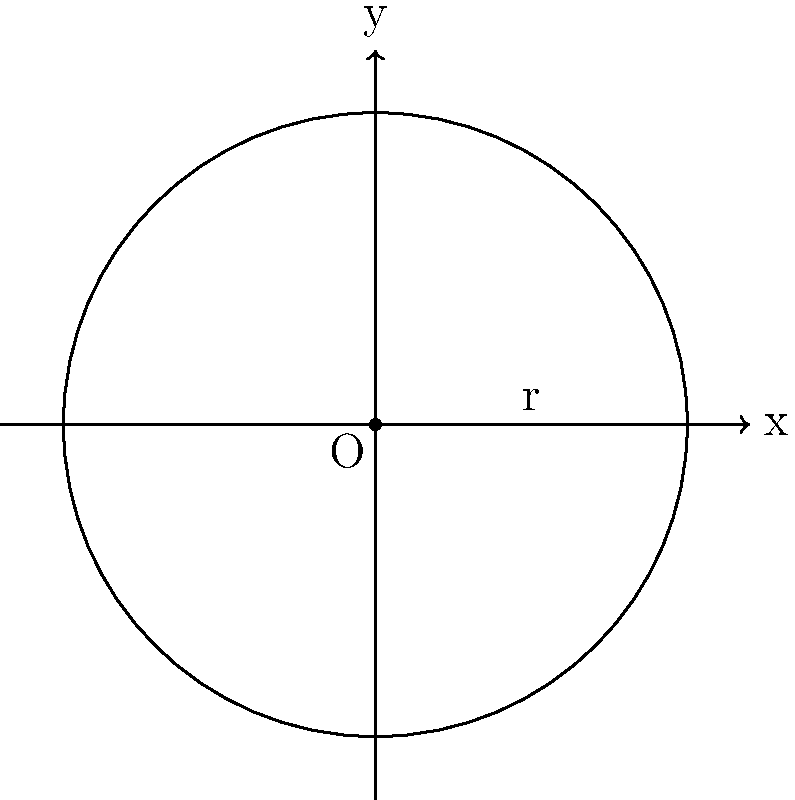As a jazz radio DJ, you're planning a special vinyl-only broadcast. You have a rare 10-inch jazz record that you want to feature. If the radius of this record is represented by 5 units on the coordinate system shown above, what is the area of the record in square units? Use $\pi = 3.14$ for your calculation. To find the area of the circular vinyl record, we'll use the formula for the area of a circle:

$$A = \pi r^2$$

Where:
$A$ = area of the circle
$\pi$ = pi (given as 3.14)
$r$ = radius of the circle

Steps:
1. Identify the radius: $r = 5$ units
2. Square the radius: $r^2 = 5^2 = 25$
3. Multiply by $\pi$: $A = 3.14 \times 25$
4. Calculate the final result: $A = 78.5$ square units

Therefore, the area of the vinyl record is 78.5 square units.
Answer: 78.5 square units 